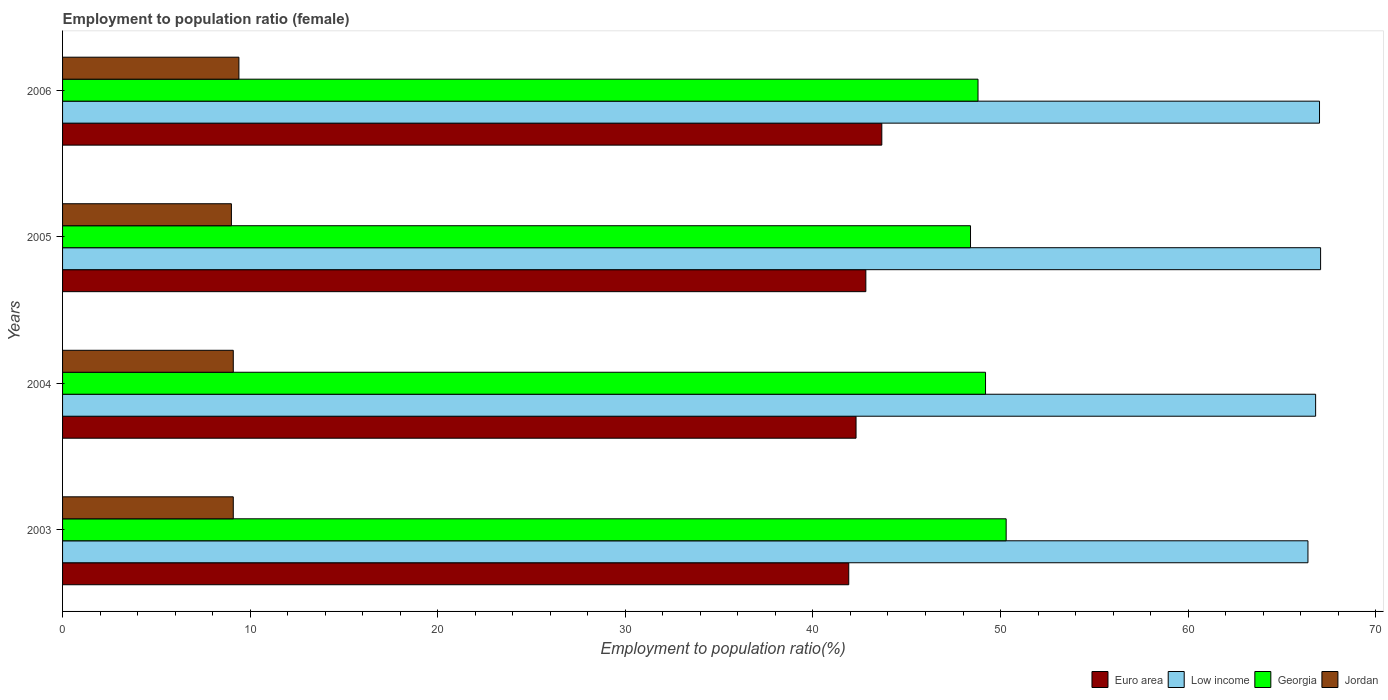How many groups of bars are there?
Provide a short and direct response. 4. Are the number of bars per tick equal to the number of legend labels?
Give a very brief answer. Yes. How many bars are there on the 2nd tick from the bottom?
Provide a succinct answer. 4. What is the label of the 4th group of bars from the top?
Your answer should be very brief. 2003. What is the employment to population ratio in Georgia in 2005?
Make the answer very short. 48.4. Across all years, what is the maximum employment to population ratio in Low income?
Make the answer very short. 67.06. Across all years, what is the minimum employment to population ratio in Euro area?
Provide a short and direct response. 41.91. In which year was the employment to population ratio in Euro area maximum?
Provide a succinct answer. 2006. What is the total employment to population ratio in Jordan in the graph?
Provide a short and direct response. 36.6. What is the difference between the employment to population ratio in Euro area in 2003 and that in 2006?
Provide a succinct answer. -1.76. What is the difference between the employment to population ratio in Euro area in 2006 and the employment to population ratio in Low income in 2005?
Your response must be concise. -23.39. What is the average employment to population ratio in Jordan per year?
Offer a very short reply. 9.15. In the year 2004, what is the difference between the employment to population ratio in Euro area and employment to population ratio in Jordan?
Provide a short and direct response. 33.2. In how many years, is the employment to population ratio in Georgia greater than 32 %?
Your answer should be compact. 4. What is the ratio of the employment to population ratio in Georgia in 2005 to that in 2006?
Provide a succinct answer. 0.99. What is the difference between the highest and the second highest employment to population ratio in Jordan?
Your answer should be very brief. 0.3. What is the difference between the highest and the lowest employment to population ratio in Low income?
Your answer should be compact. 0.67. In how many years, is the employment to population ratio in Euro area greater than the average employment to population ratio in Euro area taken over all years?
Offer a very short reply. 2. Is the sum of the employment to population ratio in Euro area in 2005 and 2006 greater than the maximum employment to population ratio in Jordan across all years?
Your answer should be very brief. Yes. What does the 1st bar from the top in 2004 represents?
Your response must be concise. Jordan. What does the 4th bar from the bottom in 2005 represents?
Provide a short and direct response. Jordan. Is it the case that in every year, the sum of the employment to population ratio in Jordan and employment to population ratio in Georgia is greater than the employment to population ratio in Euro area?
Your answer should be compact. Yes. How many years are there in the graph?
Offer a very short reply. 4. What is the difference between two consecutive major ticks on the X-axis?
Your answer should be compact. 10. Are the values on the major ticks of X-axis written in scientific E-notation?
Your response must be concise. No. Does the graph contain grids?
Provide a short and direct response. No. Where does the legend appear in the graph?
Your answer should be compact. Bottom right. How many legend labels are there?
Make the answer very short. 4. How are the legend labels stacked?
Provide a short and direct response. Horizontal. What is the title of the graph?
Your answer should be very brief. Employment to population ratio (female). Does "Heavily indebted poor countries" appear as one of the legend labels in the graph?
Your answer should be very brief. No. What is the Employment to population ratio(%) of Euro area in 2003?
Your response must be concise. 41.91. What is the Employment to population ratio(%) of Low income in 2003?
Offer a very short reply. 66.39. What is the Employment to population ratio(%) of Georgia in 2003?
Offer a very short reply. 50.3. What is the Employment to population ratio(%) of Jordan in 2003?
Make the answer very short. 9.1. What is the Employment to population ratio(%) of Euro area in 2004?
Keep it short and to the point. 42.3. What is the Employment to population ratio(%) of Low income in 2004?
Ensure brevity in your answer.  66.8. What is the Employment to population ratio(%) in Georgia in 2004?
Keep it short and to the point. 49.2. What is the Employment to population ratio(%) of Jordan in 2004?
Your answer should be very brief. 9.1. What is the Employment to population ratio(%) in Euro area in 2005?
Your answer should be compact. 42.82. What is the Employment to population ratio(%) of Low income in 2005?
Provide a succinct answer. 67.06. What is the Employment to population ratio(%) in Georgia in 2005?
Give a very brief answer. 48.4. What is the Employment to population ratio(%) in Jordan in 2005?
Ensure brevity in your answer.  9. What is the Employment to population ratio(%) in Euro area in 2006?
Offer a terse response. 43.67. What is the Employment to population ratio(%) in Low income in 2006?
Provide a short and direct response. 67. What is the Employment to population ratio(%) of Georgia in 2006?
Your response must be concise. 48.8. What is the Employment to population ratio(%) of Jordan in 2006?
Keep it short and to the point. 9.4. Across all years, what is the maximum Employment to population ratio(%) in Euro area?
Provide a succinct answer. 43.67. Across all years, what is the maximum Employment to population ratio(%) of Low income?
Your answer should be very brief. 67.06. Across all years, what is the maximum Employment to population ratio(%) of Georgia?
Keep it short and to the point. 50.3. Across all years, what is the maximum Employment to population ratio(%) of Jordan?
Make the answer very short. 9.4. Across all years, what is the minimum Employment to population ratio(%) of Euro area?
Offer a very short reply. 41.91. Across all years, what is the minimum Employment to population ratio(%) of Low income?
Your response must be concise. 66.39. Across all years, what is the minimum Employment to population ratio(%) of Georgia?
Provide a succinct answer. 48.4. What is the total Employment to population ratio(%) in Euro area in the graph?
Give a very brief answer. 170.7. What is the total Employment to population ratio(%) in Low income in the graph?
Ensure brevity in your answer.  267.25. What is the total Employment to population ratio(%) of Georgia in the graph?
Ensure brevity in your answer.  196.7. What is the total Employment to population ratio(%) of Jordan in the graph?
Provide a short and direct response. 36.6. What is the difference between the Employment to population ratio(%) in Euro area in 2003 and that in 2004?
Offer a terse response. -0.39. What is the difference between the Employment to population ratio(%) of Low income in 2003 and that in 2004?
Offer a very short reply. -0.41. What is the difference between the Employment to population ratio(%) of Georgia in 2003 and that in 2004?
Give a very brief answer. 1.1. What is the difference between the Employment to population ratio(%) of Euro area in 2003 and that in 2005?
Your response must be concise. -0.91. What is the difference between the Employment to population ratio(%) of Low income in 2003 and that in 2005?
Your response must be concise. -0.67. What is the difference between the Employment to population ratio(%) in Euro area in 2003 and that in 2006?
Provide a succinct answer. -1.76. What is the difference between the Employment to population ratio(%) of Low income in 2003 and that in 2006?
Provide a short and direct response. -0.62. What is the difference between the Employment to population ratio(%) of Georgia in 2003 and that in 2006?
Provide a succinct answer. 1.5. What is the difference between the Employment to population ratio(%) of Jordan in 2003 and that in 2006?
Offer a very short reply. -0.3. What is the difference between the Employment to population ratio(%) of Euro area in 2004 and that in 2005?
Ensure brevity in your answer.  -0.52. What is the difference between the Employment to population ratio(%) of Low income in 2004 and that in 2005?
Your answer should be compact. -0.26. What is the difference between the Employment to population ratio(%) in Georgia in 2004 and that in 2005?
Make the answer very short. 0.8. What is the difference between the Employment to population ratio(%) of Jordan in 2004 and that in 2005?
Make the answer very short. 0.1. What is the difference between the Employment to population ratio(%) of Euro area in 2004 and that in 2006?
Provide a succinct answer. -1.37. What is the difference between the Employment to population ratio(%) in Low income in 2004 and that in 2006?
Your answer should be compact. -0.21. What is the difference between the Employment to population ratio(%) of Jordan in 2004 and that in 2006?
Make the answer very short. -0.3. What is the difference between the Employment to population ratio(%) in Euro area in 2005 and that in 2006?
Your response must be concise. -0.85. What is the difference between the Employment to population ratio(%) in Low income in 2005 and that in 2006?
Make the answer very short. 0.06. What is the difference between the Employment to population ratio(%) of Jordan in 2005 and that in 2006?
Your answer should be very brief. -0.4. What is the difference between the Employment to population ratio(%) of Euro area in 2003 and the Employment to population ratio(%) of Low income in 2004?
Offer a very short reply. -24.89. What is the difference between the Employment to population ratio(%) of Euro area in 2003 and the Employment to population ratio(%) of Georgia in 2004?
Your answer should be very brief. -7.29. What is the difference between the Employment to population ratio(%) in Euro area in 2003 and the Employment to population ratio(%) in Jordan in 2004?
Make the answer very short. 32.81. What is the difference between the Employment to population ratio(%) of Low income in 2003 and the Employment to population ratio(%) of Georgia in 2004?
Provide a succinct answer. 17.19. What is the difference between the Employment to population ratio(%) of Low income in 2003 and the Employment to population ratio(%) of Jordan in 2004?
Provide a succinct answer. 57.29. What is the difference between the Employment to population ratio(%) of Georgia in 2003 and the Employment to population ratio(%) of Jordan in 2004?
Your response must be concise. 41.2. What is the difference between the Employment to population ratio(%) of Euro area in 2003 and the Employment to population ratio(%) of Low income in 2005?
Ensure brevity in your answer.  -25.15. What is the difference between the Employment to population ratio(%) in Euro area in 2003 and the Employment to population ratio(%) in Georgia in 2005?
Offer a terse response. -6.49. What is the difference between the Employment to population ratio(%) of Euro area in 2003 and the Employment to population ratio(%) of Jordan in 2005?
Give a very brief answer. 32.91. What is the difference between the Employment to population ratio(%) in Low income in 2003 and the Employment to population ratio(%) in Georgia in 2005?
Ensure brevity in your answer.  17.99. What is the difference between the Employment to population ratio(%) of Low income in 2003 and the Employment to population ratio(%) of Jordan in 2005?
Your answer should be compact. 57.39. What is the difference between the Employment to population ratio(%) of Georgia in 2003 and the Employment to population ratio(%) of Jordan in 2005?
Your answer should be very brief. 41.3. What is the difference between the Employment to population ratio(%) in Euro area in 2003 and the Employment to population ratio(%) in Low income in 2006?
Your answer should be very brief. -25.09. What is the difference between the Employment to population ratio(%) in Euro area in 2003 and the Employment to population ratio(%) in Georgia in 2006?
Keep it short and to the point. -6.89. What is the difference between the Employment to population ratio(%) in Euro area in 2003 and the Employment to population ratio(%) in Jordan in 2006?
Provide a short and direct response. 32.51. What is the difference between the Employment to population ratio(%) in Low income in 2003 and the Employment to population ratio(%) in Georgia in 2006?
Offer a very short reply. 17.59. What is the difference between the Employment to population ratio(%) in Low income in 2003 and the Employment to population ratio(%) in Jordan in 2006?
Keep it short and to the point. 56.99. What is the difference between the Employment to population ratio(%) in Georgia in 2003 and the Employment to population ratio(%) in Jordan in 2006?
Offer a terse response. 40.9. What is the difference between the Employment to population ratio(%) in Euro area in 2004 and the Employment to population ratio(%) in Low income in 2005?
Give a very brief answer. -24.76. What is the difference between the Employment to population ratio(%) in Euro area in 2004 and the Employment to population ratio(%) in Georgia in 2005?
Make the answer very short. -6.1. What is the difference between the Employment to population ratio(%) in Euro area in 2004 and the Employment to population ratio(%) in Jordan in 2005?
Your response must be concise. 33.3. What is the difference between the Employment to population ratio(%) of Low income in 2004 and the Employment to population ratio(%) of Georgia in 2005?
Offer a terse response. 18.4. What is the difference between the Employment to population ratio(%) of Low income in 2004 and the Employment to population ratio(%) of Jordan in 2005?
Keep it short and to the point. 57.8. What is the difference between the Employment to population ratio(%) of Georgia in 2004 and the Employment to population ratio(%) of Jordan in 2005?
Offer a very short reply. 40.2. What is the difference between the Employment to population ratio(%) in Euro area in 2004 and the Employment to population ratio(%) in Low income in 2006?
Keep it short and to the point. -24.71. What is the difference between the Employment to population ratio(%) in Euro area in 2004 and the Employment to population ratio(%) in Georgia in 2006?
Your answer should be very brief. -6.5. What is the difference between the Employment to population ratio(%) of Euro area in 2004 and the Employment to population ratio(%) of Jordan in 2006?
Your response must be concise. 32.9. What is the difference between the Employment to population ratio(%) in Low income in 2004 and the Employment to population ratio(%) in Georgia in 2006?
Make the answer very short. 18. What is the difference between the Employment to population ratio(%) in Low income in 2004 and the Employment to population ratio(%) in Jordan in 2006?
Offer a terse response. 57.4. What is the difference between the Employment to population ratio(%) in Georgia in 2004 and the Employment to population ratio(%) in Jordan in 2006?
Make the answer very short. 39.8. What is the difference between the Employment to population ratio(%) of Euro area in 2005 and the Employment to population ratio(%) of Low income in 2006?
Give a very brief answer. -24.18. What is the difference between the Employment to population ratio(%) of Euro area in 2005 and the Employment to population ratio(%) of Georgia in 2006?
Ensure brevity in your answer.  -5.98. What is the difference between the Employment to population ratio(%) in Euro area in 2005 and the Employment to population ratio(%) in Jordan in 2006?
Your answer should be very brief. 33.42. What is the difference between the Employment to population ratio(%) of Low income in 2005 and the Employment to population ratio(%) of Georgia in 2006?
Your answer should be very brief. 18.26. What is the difference between the Employment to population ratio(%) of Low income in 2005 and the Employment to population ratio(%) of Jordan in 2006?
Ensure brevity in your answer.  57.66. What is the average Employment to population ratio(%) of Euro area per year?
Make the answer very short. 42.67. What is the average Employment to population ratio(%) in Low income per year?
Your answer should be compact. 66.81. What is the average Employment to population ratio(%) of Georgia per year?
Your answer should be compact. 49.17. What is the average Employment to population ratio(%) in Jordan per year?
Offer a terse response. 9.15. In the year 2003, what is the difference between the Employment to population ratio(%) in Euro area and Employment to population ratio(%) in Low income?
Keep it short and to the point. -24.48. In the year 2003, what is the difference between the Employment to population ratio(%) of Euro area and Employment to population ratio(%) of Georgia?
Your answer should be very brief. -8.39. In the year 2003, what is the difference between the Employment to population ratio(%) in Euro area and Employment to population ratio(%) in Jordan?
Your answer should be compact. 32.81. In the year 2003, what is the difference between the Employment to population ratio(%) of Low income and Employment to population ratio(%) of Georgia?
Keep it short and to the point. 16.09. In the year 2003, what is the difference between the Employment to population ratio(%) in Low income and Employment to population ratio(%) in Jordan?
Your answer should be compact. 57.29. In the year 2003, what is the difference between the Employment to population ratio(%) in Georgia and Employment to population ratio(%) in Jordan?
Your answer should be compact. 41.2. In the year 2004, what is the difference between the Employment to population ratio(%) of Euro area and Employment to population ratio(%) of Low income?
Offer a terse response. -24.5. In the year 2004, what is the difference between the Employment to population ratio(%) of Euro area and Employment to population ratio(%) of Georgia?
Your answer should be very brief. -6.9. In the year 2004, what is the difference between the Employment to population ratio(%) in Euro area and Employment to population ratio(%) in Jordan?
Keep it short and to the point. 33.2. In the year 2004, what is the difference between the Employment to population ratio(%) of Low income and Employment to population ratio(%) of Georgia?
Provide a succinct answer. 17.6. In the year 2004, what is the difference between the Employment to population ratio(%) in Low income and Employment to population ratio(%) in Jordan?
Make the answer very short. 57.7. In the year 2004, what is the difference between the Employment to population ratio(%) of Georgia and Employment to population ratio(%) of Jordan?
Offer a very short reply. 40.1. In the year 2005, what is the difference between the Employment to population ratio(%) in Euro area and Employment to population ratio(%) in Low income?
Provide a short and direct response. -24.24. In the year 2005, what is the difference between the Employment to population ratio(%) in Euro area and Employment to population ratio(%) in Georgia?
Offer a very short reply. -5.58. In the year 2005, what is the difference between the Employment to population ratio(%) of Euro area and Employment to population ratio(%) of Jordan?
Make the answer very short. 33.82. In the year 2005, what is the difference between the Employment to population ratio(%) in Low income and Employment to population ratio(%) in Georgia?
Offer a very short reply. 18.66. In the year 2005, what is the difference between the Employment to population ratio(%) of Low income and Employment to population ratio(%) of Jordan?
Offer a very short reply. 58.06. In the year 2005, what is the difference between the Employment to population ratio(%) in Georgia and Employment to population ratio(%) in Jordan?
Ensure brevity in your answer.  39.4. In the year 2006, what is the difference between the Employment to population ratio(%) of Euro area and Employment to population ratio(%) of Low income?
Offer a very short reply. -23.33. In the year 2006, what is the difference between the Employment to population ratio(%) of Euro area and Employment to population ratio(%) of Georgia?
Your answer should be compact. -5.13. In the year 2006, what is the difference between the Employment to population ratio(%) of Euro area and Employment to population ratio(%) of Jordan?
Provide a short and direct response. 34.27. In the year 2006, what is the difference between the Employment to population ratio(%) of Low income and Employment to population ratio(%) of Georgia?
Ensure brevity in your answer.  18.2. In the year 2006, what is the difference between the Employment to population ratio(%) in Low income and Employment to population ratio(%) in Jordan?
Your answer should be very brief. 57.6. In the year 2006, what is the difference between the Employment to population ratio(%) of Georgia and Employment to population ratio(%) of Jordan?
Offer a terse response. 39.4. What is the ratio of the Employment to population ratio(%) in Euro area in 2003 to that in 2004?
Keep it short and to the point. 0.99. What is the ratio of the Employment to population ratio(%) of Low income in 2003 to that in 2004?
Your answer should be compact. 0.99. What is the ratio of the Employment to population ratio(%) in Georgia in 2003 to that in 2004?
Make the answer very short. 1.02. What is the ratio of the Employment to population ratio(%) in Euro area in 2003 to that in 2005?
Offer a terse response. 0.98. What is the ratio of the Employment to population ratio(%) in Georgia in 2003 to that in 2005?
Keep it short and to the point. 1.04. What is the ratio of the Employment to population ratio(%) in Jordan in 2003 to that in 2005?
Provide a short and direct response. 1.01. What is the ratio of the Employment to population ratio(%) in Euro area in 2003 to that in 2006?
Your answer should be compact. 0.96. What is the ratio of the Employment to population ratio(%) in Low income in 2003 to that in 2006?
Keep it short and to the point. 0.99. What is the ratio of the Employment to population ratio(%) of Georgia in 2003 to that in 2006?
Give a very brief answer. 1.03. What is the ratio of the Employment to population ratio(%) of Jordan in 2003 to that in 2006?
Provide a short and direct response. 0.97. What is the ratio of the Employment to population ratio(%) in Low income in 2004 to that in 2005?
Your response must be concise. 1. What is the ratio of the Employment to population ratio(%) in Georgia in 2004 to that in 2005?
Ensure brevity in your answer.  1.02. What is the ratio of the Employment to population ratio(%) of Jordan in 2004 to that in 2005?
Give a very brief answer. 1.01. What is the ratio of the Employment to population ratio(%) of Euro area in 2004 to that in 2006?
Provide a succinct answer. 0.97. What is the ratio of the Employment to population ratio(%) in Low income in 2004 to that in 2006?
Make the answer very short. 1. What is the ratio of the Employment to population ratio(%) of Georgia in 2004 to that in 2006?
Offer a very short reply. 1.01. What is the ratio of the Employment to population ratio(%) of Jordan in 2004 to that in 2006?
Keep it short and to the point. 0.97. What is the ratio of the Employment to population ratio(%) in Euro area in 2005 to that in 2006?
Ensure brevity in your answer.  0.98. What is the ratio of the Employment to population ratio(%) in Georgia in 2005 to that in 2006?
Give a very brief answer. 0.99. What is the ratio of the Employment to population ratio(%) of Jordan in 2005 to that in 2006?
Provide a succinct answer. 0.96. What is the difference between the highest and the second highest Employment to population ratio(%) in Euro area?
Your response must be concise. 0.85. What is the difference between the highest and the second highest Employment to population ratio(%) in Low income?
Give a very brief answer. 0.06. What is the difference between the highest and the lowest Employment to population ratio(%) of Euro area?
Your answer should be compact. 1.76. What is the difference between the highest and the lowest Employment to population ratio(%) in Low income?
Provide a short and direct response. 0.67. 